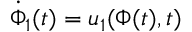<formula> <loc_0><loc_0><loc_500><loc_500>\dot { \Phi } _ { 1 } ( t ) = u _ { 1 } ( \Phi ( t ) , t )</formula> 